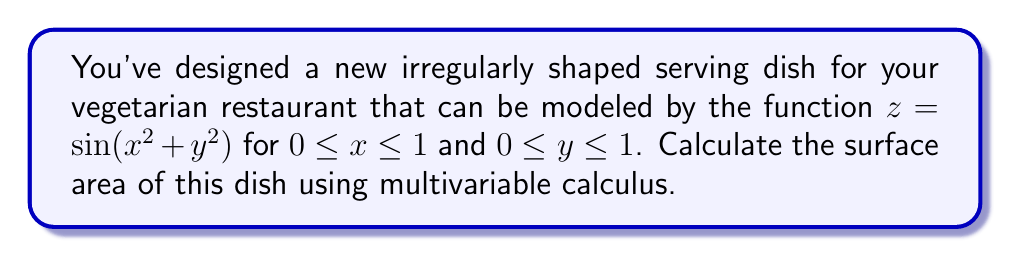Can you solve this math problem? To calculate the surface area of the dish, we need to use the surface area formula for a function $z = f(x,y)$:

$$SA = \iint_R \sqrt{1 + \left(\frac{\partial z}{\partial x}\right)^2 + \left(\frac{\partial z}{\partial y}\right)^2} \, dA$$

where $R$ is the region of integration.

Step 1: Calculate partial derivatives
$\frac{\partial z}{\partial x} = 2x \cos(x^2 + y^2)$
$\frac{\partial z}{\partial y} = 2y \cos(x^2 + y^2)$

Step 2: Substitute into the surface area formula
$$SA = \int_0^1 \int_0^1 \sqrt{1 + (2x \cos(x^2 + y^2))^2 + (2y \cos(x^2 + y^2))^2} \, dy \, dx$$

Step 3: Simplify the integrand
$$SA = \int_0^1 \int_0^1 \sqrt{1 + 4(x^2 + y^2) \cos^2(x^2 + y^2)} \, dy \, dx$$

Step 4: This integral cannot be evaluated analytically, so we need to use numerical integration methods. Using a computer algebra system or numerical integration software, we can approximate the result.

The approximate surface area is 1.6211 square units.
Answer: $1.6211$ square units 